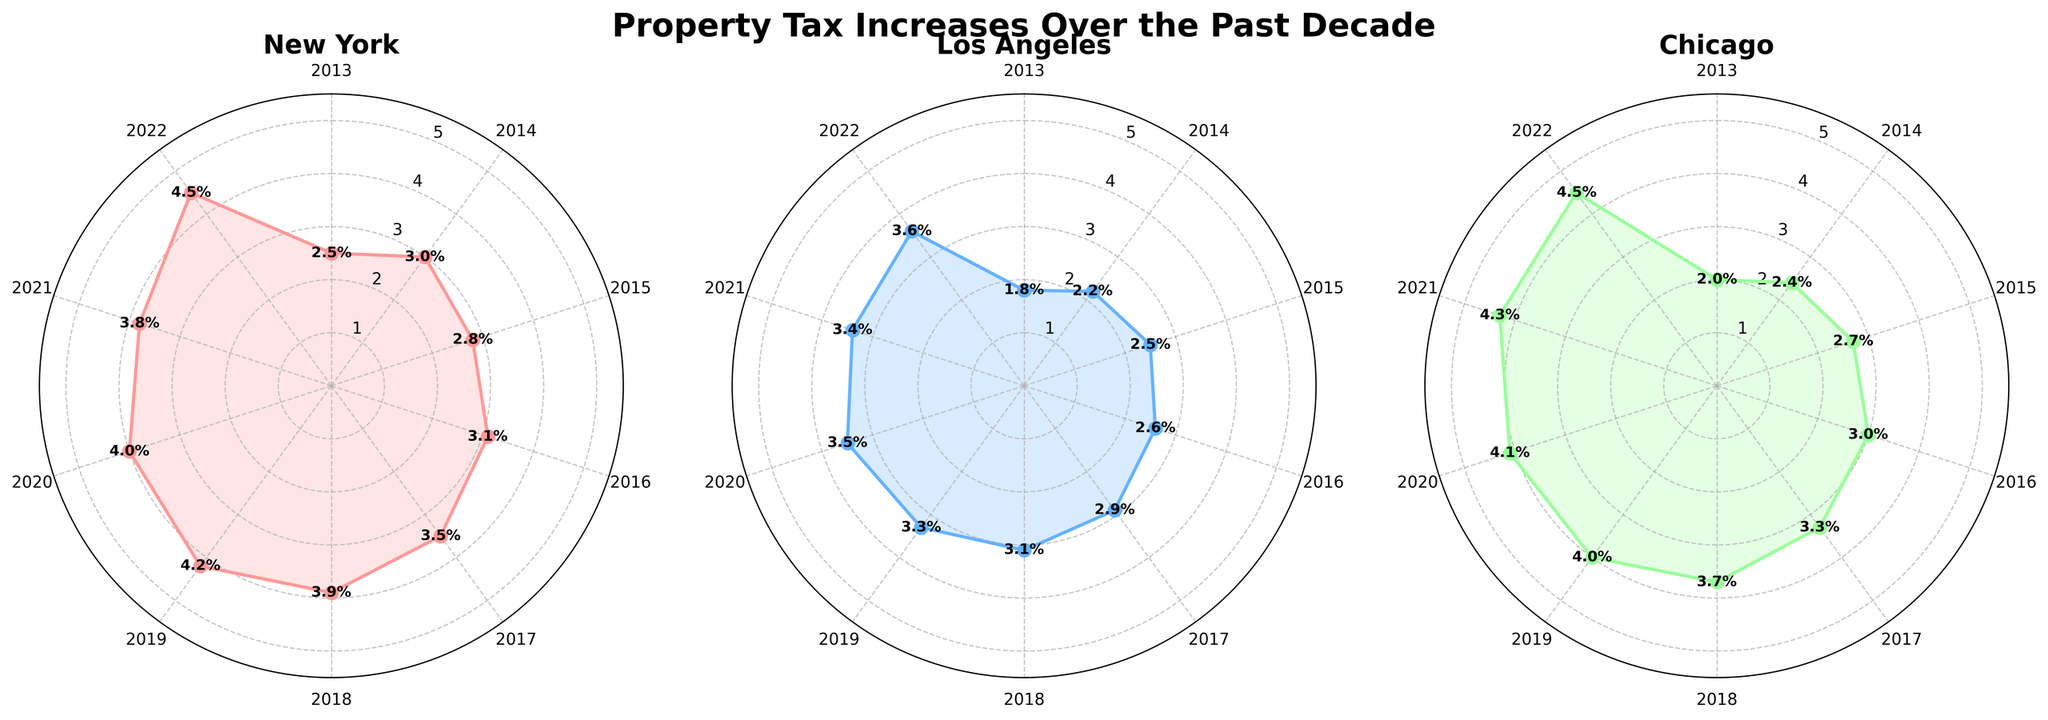What are the cities represented in the rose chart? The rose chart depicts property tax increases for three cities. Each subplot is labeled with the city's name at the top. The cities are New York, Los Angeles, and Chicago.
Answer: New York, Los Angeles, Chicago How is the property tax increase percentage in 2022 for New York? In 2022, New York's property tax increase percentage is shown as 4.5% on the rose chart. The value is marked at the end of the subplot for New York.
Answer: 4.5% Which city had the smallest property tax increase in 2013? To determine the smallest increase in 2013, check the initial points of each subplot. New York had 2.5%, Los Angeles had 1.8%, and Chicago had 2.0%. Therefore, Los Angeles had the smallest increase.
Answer: Los Angeles What is the average property tax increase for Chicago across the decade? To find the average, add all the annual increases for Chicago and divide by the number of years. Chicago's increases are: 2.0, 2.4, 2.7, 3.0, 3.3, 3.7, 4.0, 4.1, 4.3, 4.5. Sum is 35.0, divide by 10 years results in an average of 3.5%.
Answer: 3.5% Which city experienced the largest increase in property taxes from 2013 to 2022? By comparing the increase from 2013 to 2022 for each city: New York increased from 2.5% to 4.5% (2.0% increase), Los Angeles from 1.8% to 3.6% (1.8% increase), and Chicago from 2.0% to 4.5% (2.5% increase). Chicago experienced the largest increase.
Answer: Chicago Between Los Angeles and New York, which city had a higher property tax increase in 2019? By checking the rose charts for 2019, New York had an increase of 4.2% while Los Angeles had 3.3%. Therefore, New York had the higher increase in 2019.
Answer: New York Is the overall trend in property tax increases more stable in New York or Chicago? Stability can be assessed by comparing the variations year over year in the angles and values plotted. New York has smaller annual increases and is relatively smoother compared to Chicago, which shows more significant jumps, especially post-2017.
Answer: New York How does the property tax increase in 2020 compare across all three cities? For 2020, the rose charts indicate New York at 4.0%, Los Angeles at 3.5%, and Chicago at 4.1%. In order, the property tax increase is highest in Chicago, followed by New York and then Los Angeles.
Answer: Chicago > New York > Los Angeles What is the general shape of the rose charts for all three cities, and what does it indicate? The rose charts are roughly circular but increase in radius over time, indicating a trend of rising property taxes over the decade. Each city's chart has different levels of spikiness, reflecting the variations in tax increases year over year.
Answer: Increasing trend 